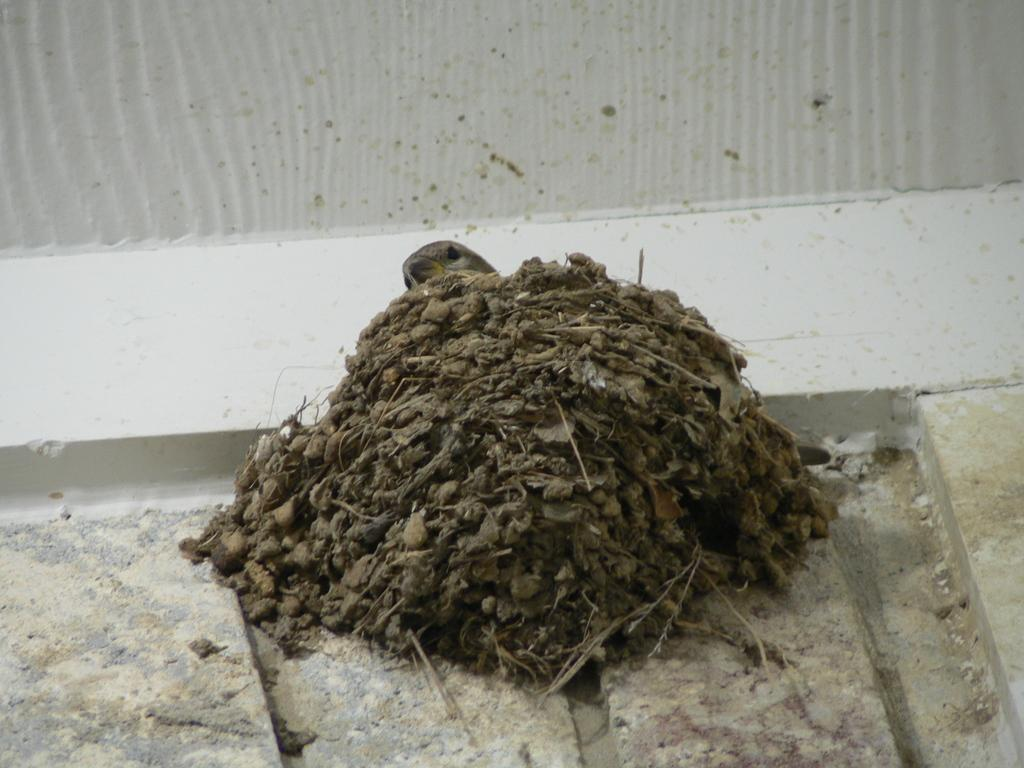What is the main subject in the center of the image? There is a bird in the center of the image. What is located near the bird in the center of the image? There is a bird nest in the center of the image. What can be seen in the background of the image? There is a wall and a few other objects in the background of the image. What type of engine is visible in the image? There is no engine present in the image. What property does the bird nest belong to in the image? The image does not provide information about the ownership or property associated with the bird nest. 